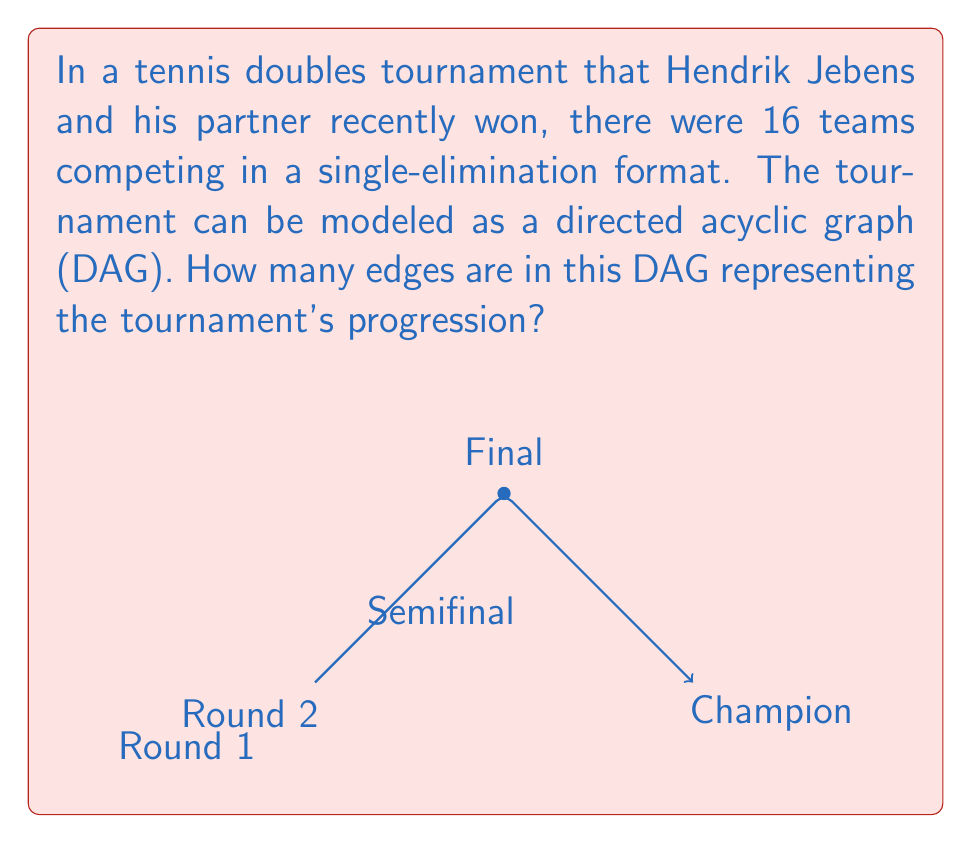Provide a solution to this math problem. Let's approach this step-by-step:

1) In a single-elimination tournament with 16 teams, there will be 4 rounds:
   - Round 1: 8 matches (16 teams → 8 winners)
   - Round 2 (Quarter-finals): 4 matches (8 teams → 4 winners)
   - Round 3 (Semi-finals): 2 matches (4 teams → 2 winners)
   - Round 4 (Final): 1 match (2 teams → 1 winner)

2) In a DAG representing this tournament:
   - Each team is represented by a node
   - Each match is represented by an edge pointing from the losing team to the winning team

3) Let's count the edges:
   - Round 1: 8 edges
   - Round 2: 4 edges
   - Round 3: 2 edges
   - Round 4: 1 edge

4) To get the total number of edges, we sum up all the edges:
   $$8 + 4 + 2 + 1 = 15$$

5) We can also derive this mathematically:
   - In a single-elimination tournament with $n$ teams, there will always be $n-1$ matches
   - Each match corresponds to one edge in the DAG
   - Therefore, the number of edges is always $n-1$

6) In this case, with 16 teams:
   $$16 - 1 = 15$$

Thus, the DAG representing this tournament has 15 edges.
Answer: 15 edges 